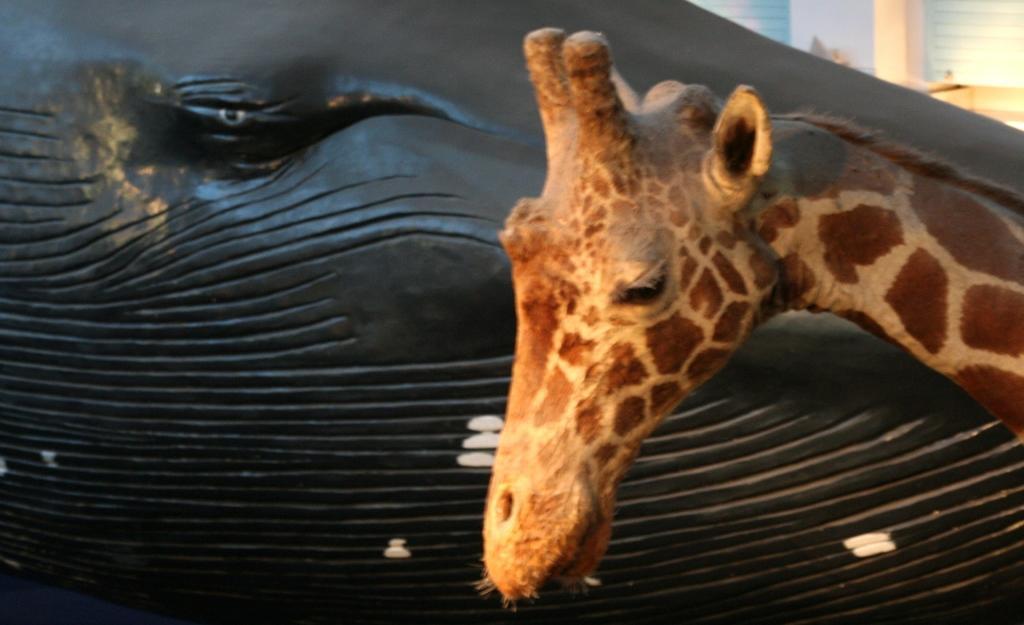How would you summarize this image in a sentence or two? In this picture I can see an artificial giraffe on the right side and looks like black color wood and I can see couple of glass windows in the back. 